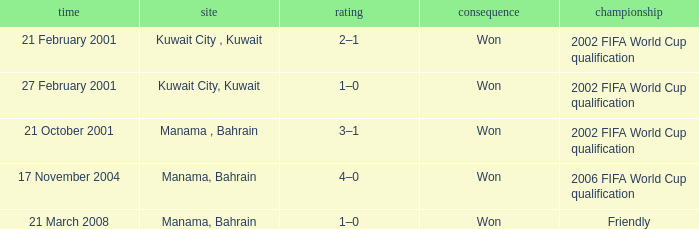On which date was the match in Manama, Bahrain? 21 October 2001, 17 November 2004, 21 March 2008. 